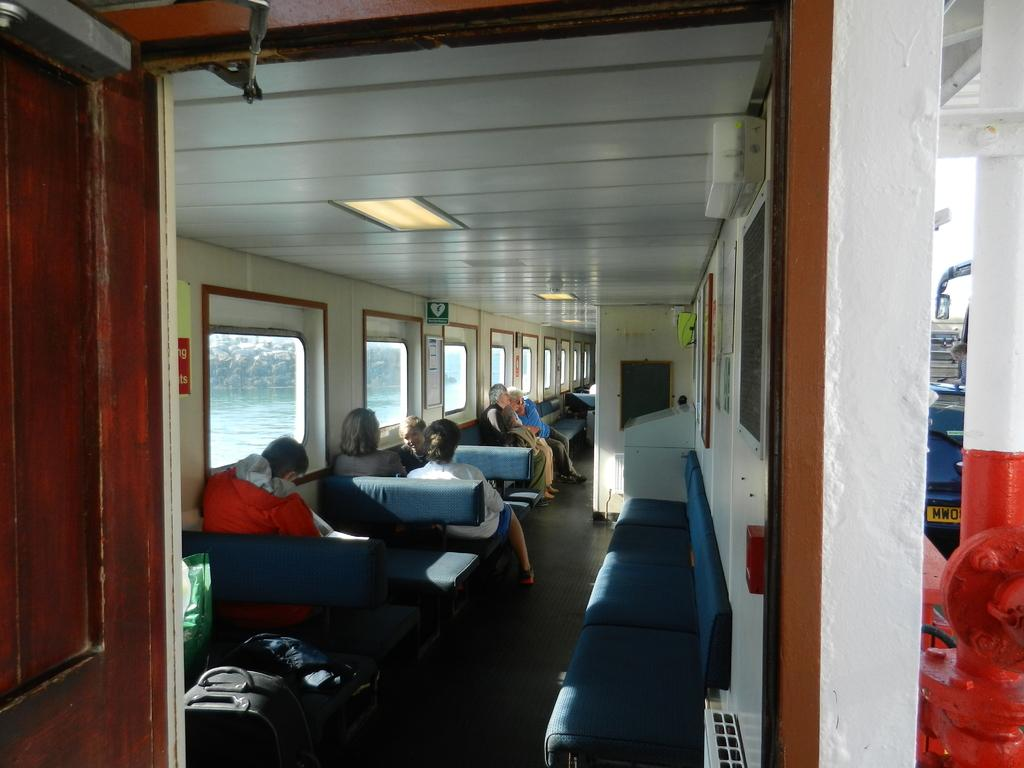How many people are in the image? There is a group of people in the image. What are the people in the image doing? The people are sitting. What can be seen in the background of the image? There are windows in the background of the image. What is visible through the windows? Water is visible through the windows. What type of lumber is being used for teaching in the image? There is no lumber or teaching activity present in the image. What flavor of juice is being served to the people in the image? There is no juice present in the image. 